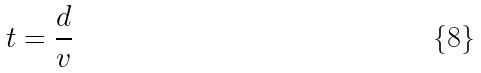<formula> <loc_0><loc_0><loc_500><loc_500>t = \frac { d } { v }</formula> 